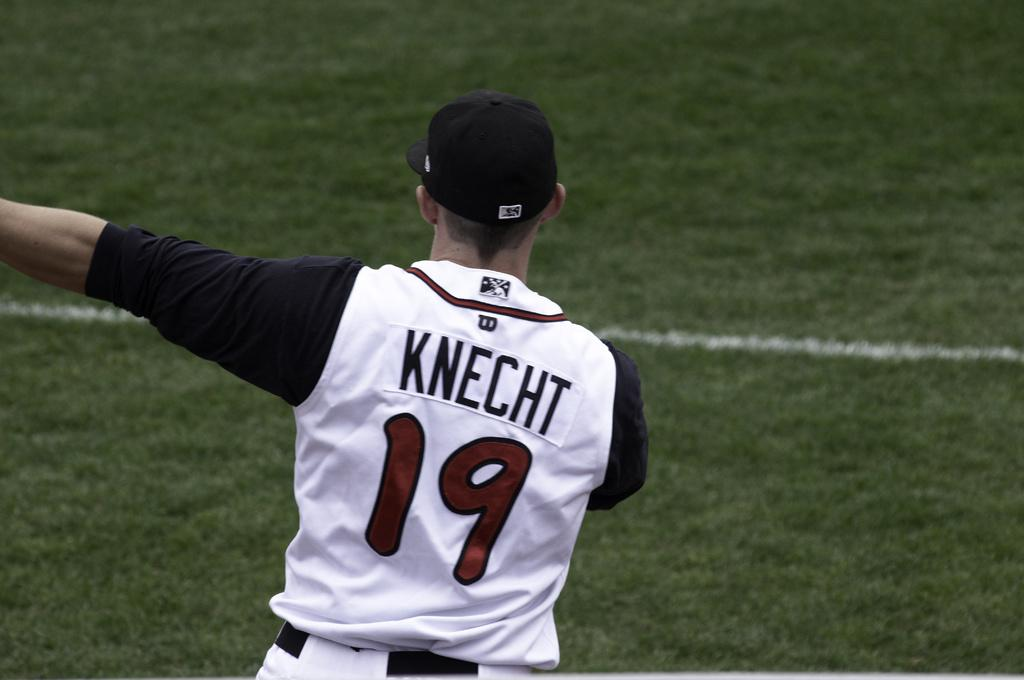<image>
Give a short and clear explanation of the subsequent image. Baseball player Knecht #19 appears to be pointing to something with his back to the camera. 